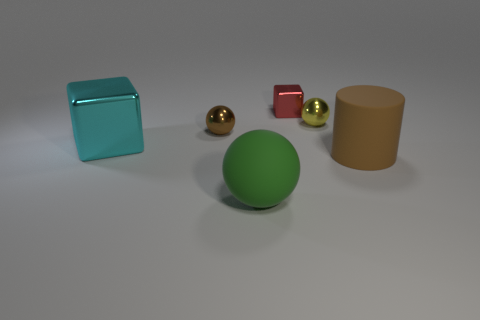Subtract 1 spheres. How many spheres are left? 2 Add 4 small yellow matte balls. How many objects exist? 10 Subtract all blocks. How many objects are left? 4 Subtract all cyan metal blocks. Subtract all big gray matte things. How many objects are left? 5 Add 2 big cyan cubes. How many big cyan cubes are left? 3 Add 1 small yellow metal spheres. How many small yellow metal spheres exist? 2 Subtract 0 cyan cylinders. How many objects are left? 6 